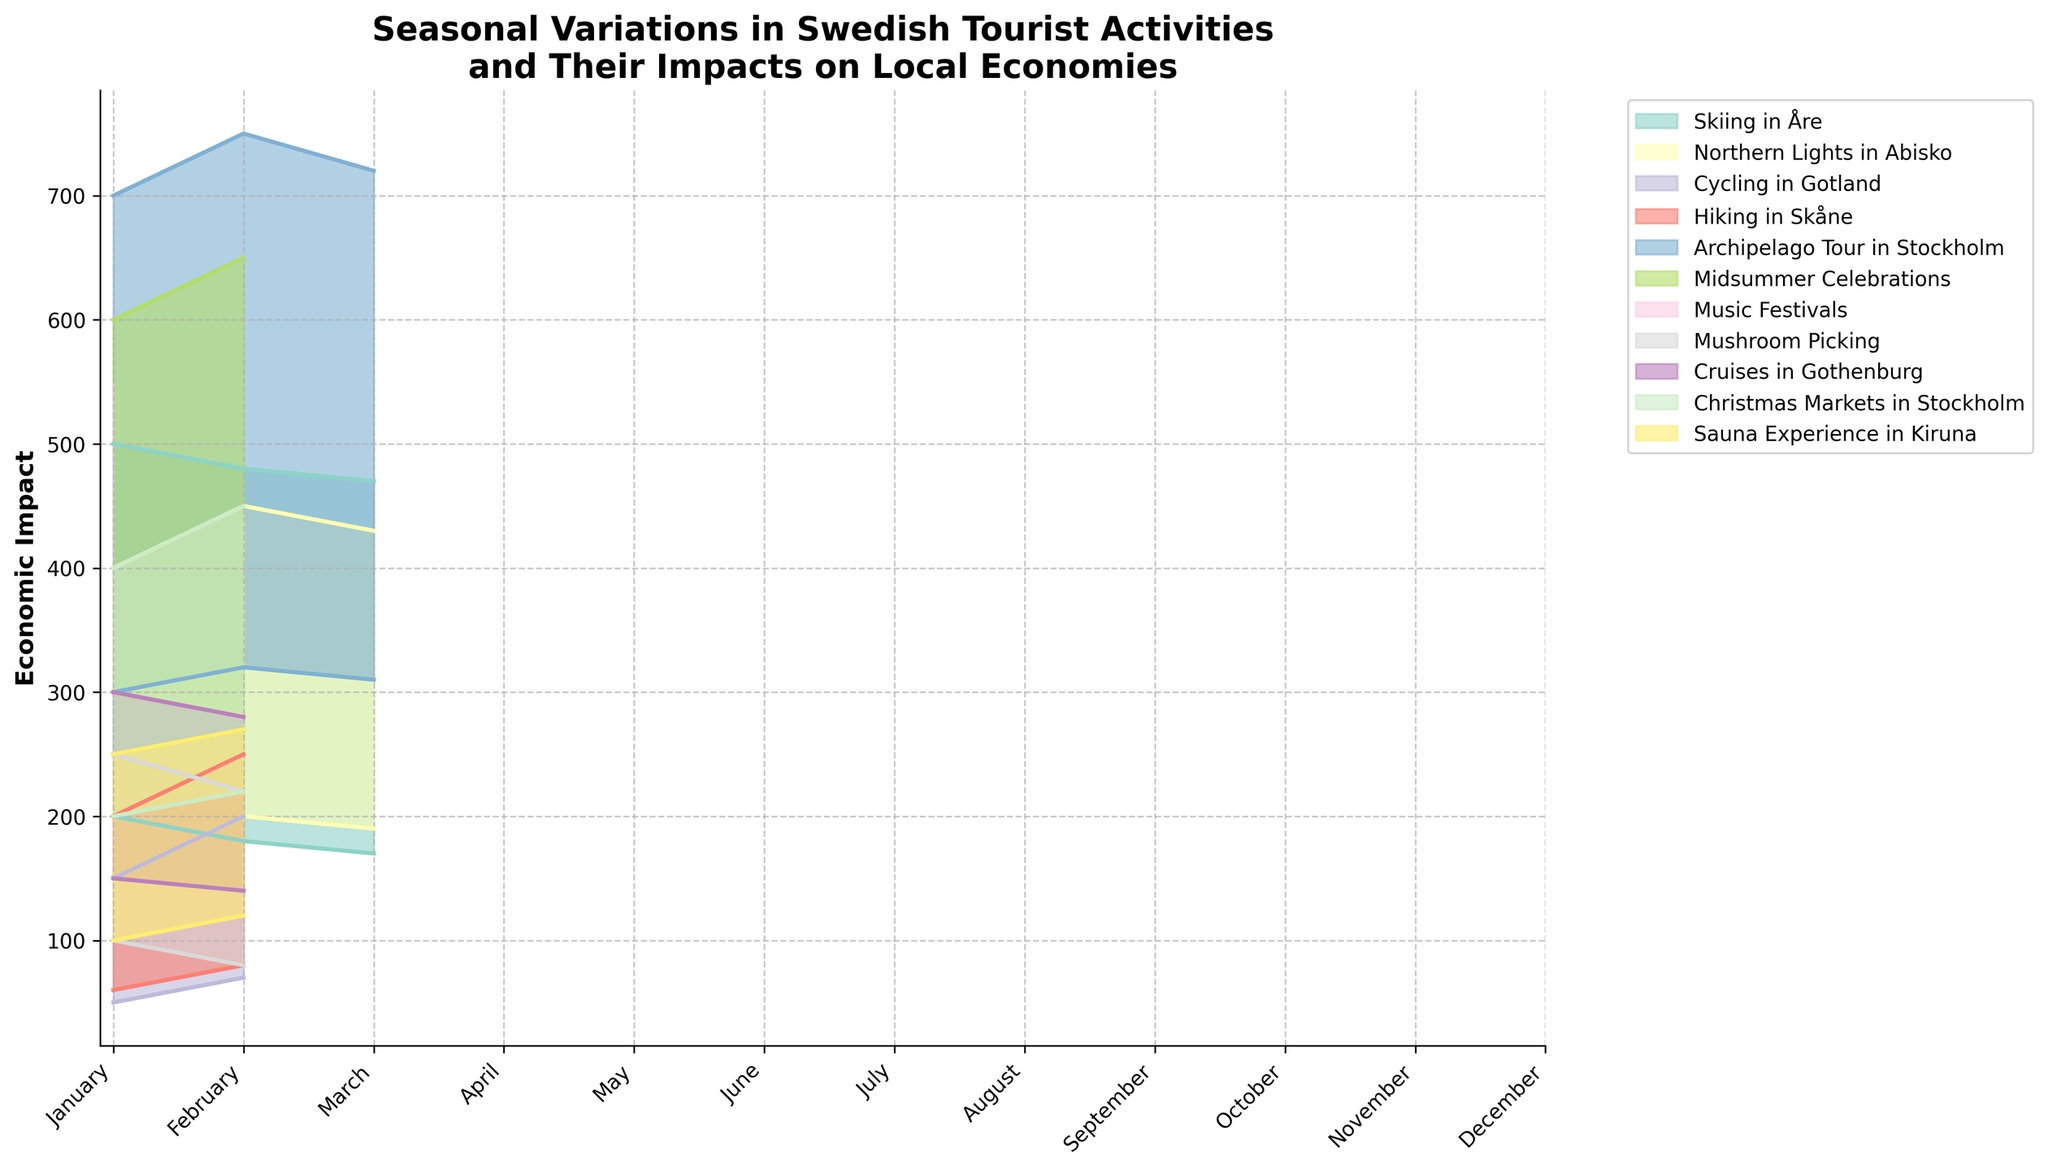What is the title of the figure? The title of the figure is usually found at the top of the chart, providing a summary of what the figure represents.
Answer: Seasonal Variations in Swedish Tourist Activities and Their Impacts on Local Economies How many tourist activities are depicted in the chart? Count the unique labels/colors in the legend that represent different tourist activities.
Answer: 12 Which month shows the highest maximum economic impact for any activity? Look for the month with the highest peak on the chart.
Answer: July What is the economic impact range for Skiing in Åre in January? Identify the range (difference between minimum and maximum) for Skiing in Åre shown in January.
Answer: 200 to 500 Which activity has the smallest economic impact range in any month? Find the activity and the month with the smallest distance between the minimum and maximum impacts.
Answer: Cycling in Gotland (April) In which month does Mushroom Picking have a higher maximum economic impact: October or September? Compare the maximum impact values for Mushroom Picking in October to those in September.
Answer: September What is the average minimum economic impact of Christmas Markets in Stockholm? Calculate the average of the minimum economic impacts for Christmas Markets in November and December.
Answer: 210 Which activity shows the largest increase in its maximum economic impact between two consecutive months? Compare the changes in maximum impact for all activities month-to-month to find the largest increase.
Answer: Archipelago Tour in Stockholm (May to June) What is the difference between the maximum economic impact of Midsummer Celebrations in July and the minimum economic impact of Sauna Experience in Kiruna in November? Subtract the minimum impact of Sauna Experience in Kiruna in November from the maximum impact of Midsummer Celebrations in July.
Answer: 650 - 100 = 550 During which month does Northern Lights in Abisko have its highest minimum economic impact? Identify the month where the minimum economic impact for Northern Lights in Abisko is at its highest point.
Answer: February 